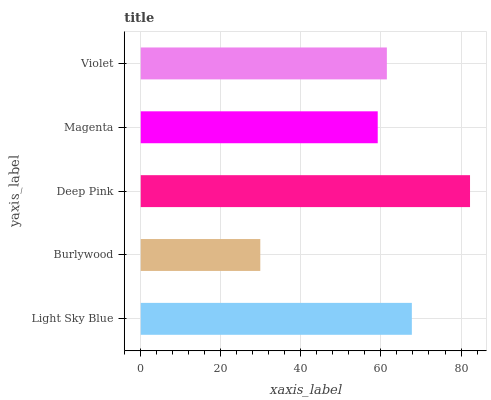Is Burlywood the minimum?
Answer yes or no. Yes. Is Deep Pink the maximum?
Answer yes or no. Yes. Is Deep Pink the minimum?
Answer yes or no. No. Is Burlywood the maximum?
Answer yes or no. No. Is Deep Pink greater than Burlywood?
Answer yes or no. Yes. Is Burlywood less than Deep Pink?
Answer yes or no. Yes. Is Burlywood greater than Deep Pink?
Answer yes or no. No. Is Deep Pink less than Burlywood?
Answer yes or no. No. Is Violet the high median?
Answer yes or no. Yes. Is Violet the low median?
Answer yes or no. Yes. Is Magenta the high median?
Answer yes or no. No. Is Light Sky Blue the low median?
Answer yes or no. No. 